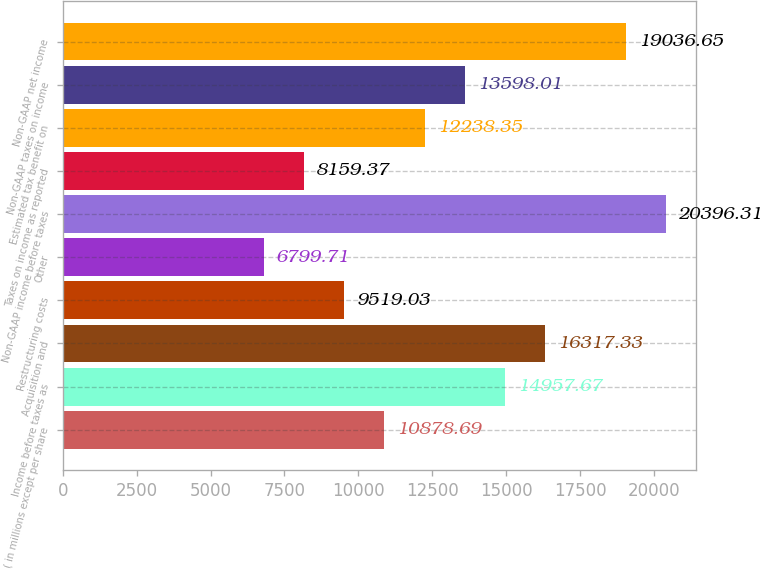Convert chart to OTSL. <chart><loc_0><loc_0><loc_500><loc_500><bar_chart><fcel>( in millions except per share<fcel>Income before taxes as<fcel>Acquisition and<fcel>Restructuring costs<fcel>Other<fcel>Non-GAAP income before taxes<fcel>Taxes on income as reported<fcel>Estimated tax benefit on<fcel>Non-GAAP taxes on income<fcel>Non-GAAP net income<nl><fcel>10878.7<fcel>14957.7<fcel>16317.3<fcel>9519.03<fcel>6799.71<fcel>20396.3<fcel>8159.37<fcel>12238.4<fcel>13598<fcel>19036.7<nl></chart> 